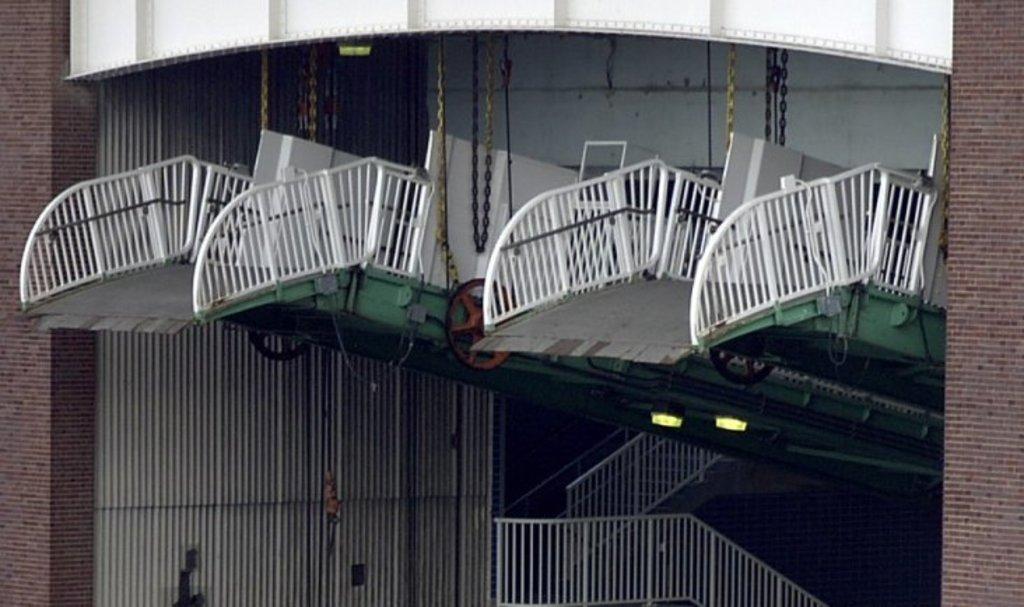Could you give a brief overview of what you see in this image? In the center of the image we can see two objects, which looks like rope bridge. And we can see two objects are tied with the ropes. And base of the objects is in green color. And we can see the wheels are attached to it. In the background there is a brick wall, staircase, fences and a few other objects. 